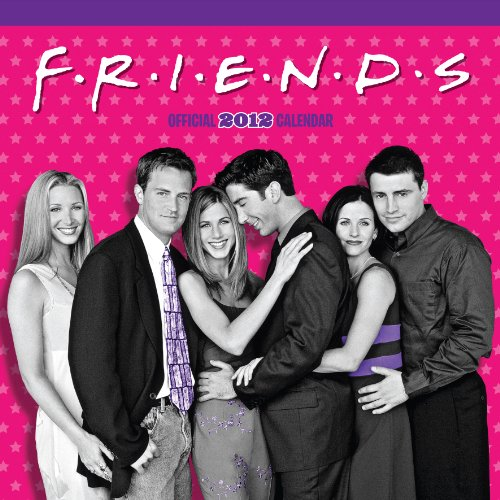What is the genre of this book? The genre of this item is 'Calendars', specifically it is a themed calendar that contains images and memorable dates from the 'Friends' TV series, providing a visual reminder of the show throughout the year. 